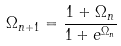<formula> <loc_0><loc_0><loc_500><loc_500>\Omega _ { n + 1 } = \frac { 1 + \Omega _ { n } } { 1 + e ^ { \Omega _ { n } } }</formula> 